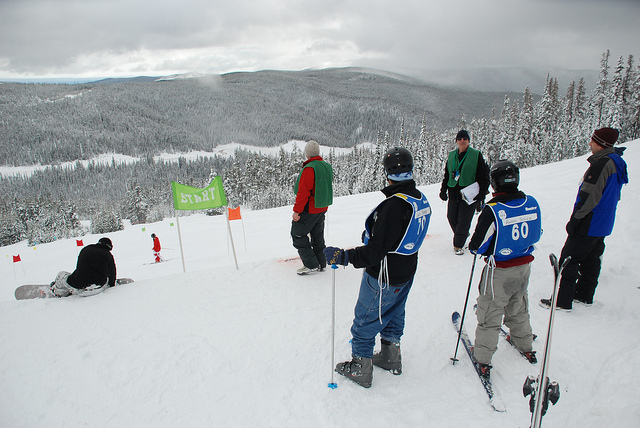Please extract the text content from this image. START 10 60 